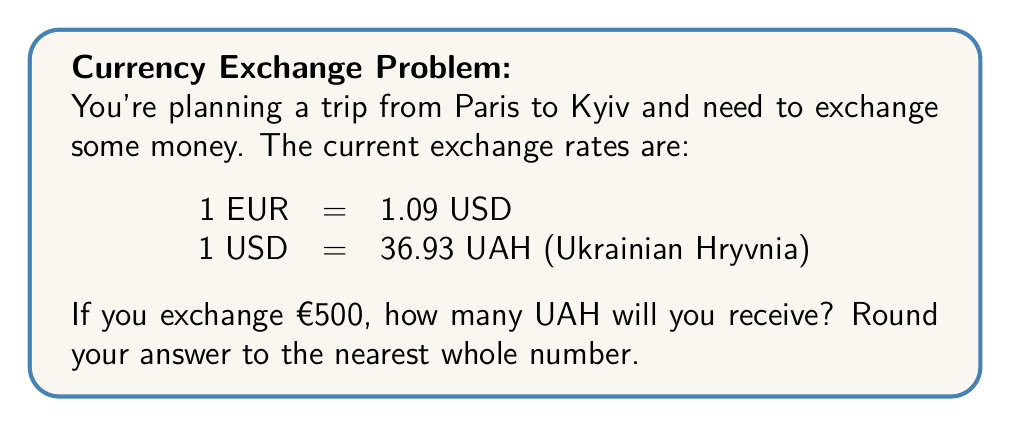Help me with this question. Let's solve this problem step by step:

1) First, we need to convert Euros (EUR) to US Dollars (USD):
   €500 * (1.09 USD/EUR) = $545 USD

2) Now, we need to convert USD to Ukrainian Hryvnia (UAH):
   $545 * (36.93 UAH/USD) = 20,126.85 UAH

3) Rounding to the nearest whole number:
   20,126.85 ≈ 20,127 UAH

The mathematical representation of this process can be written as:

$$\text{UAH} = \text{EUR} \times \frac{\text{USD}}{\text{EUR}} \times \frac{\text{UAH}}{\text{USD}}$$

$$\text{UAH} = 500 \times 1.09 \times 36.93 \approx 20,127$$
Answer: 20,127 UAH 